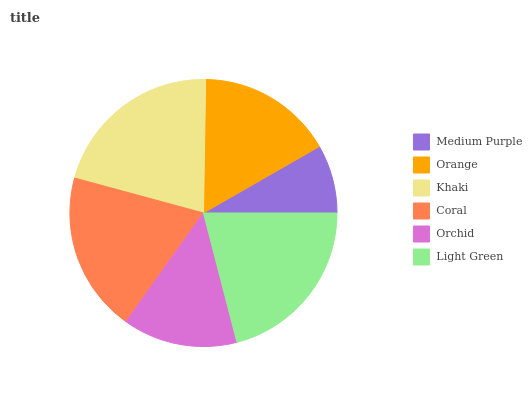Is Medium Purple the minimum?
Answer yes or no. Yes. Is Khaki the maximum?
Answer yes or no. Yes. Is Orange the minimum?
Answer yes or no. No. Is Orange the maximum?
Answer yes or no. No. Is Orange greater than Medium Purple?
Answer yes or no. Yes. Is Medium Purple less than Orange?
Answer yes or no. Yes. Is Medium Purple greater than Orange?
Answer yes or no. No. Is Orange less than Medium Purple?
Answer yes or no. No. Is Coral the high median?
Answer yes or no. Yes. Is Orange the low median?
Answer yes or no. Yes. Is Orange the high median?
Answer yes or no. No. Is Medium Purple the low median?
Answer yes or no. No. 